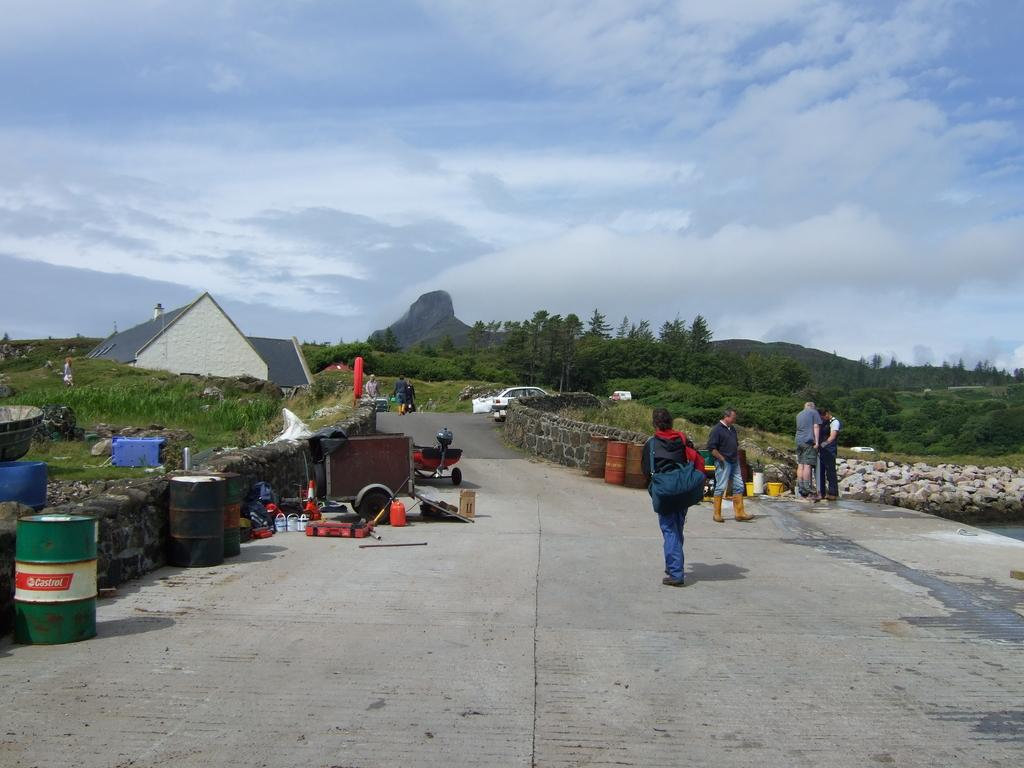How many people are in the image? There are people in the image, but the exact number is not specified. What can be seen in the background of the image? There is a road, a house, plants, trees, and the sky visible in the image. What is on the road in the image? There are objects on the road in the image. What is the condition of the sky in the image? The sky is visible in the image, and there are clouds present. Can you describe the stone in the image? Yes, there is a stone in the image. What letters are being used to spell out the name of the position in the image? There is no mention of a position or letters being used to spell out a name in the image. 